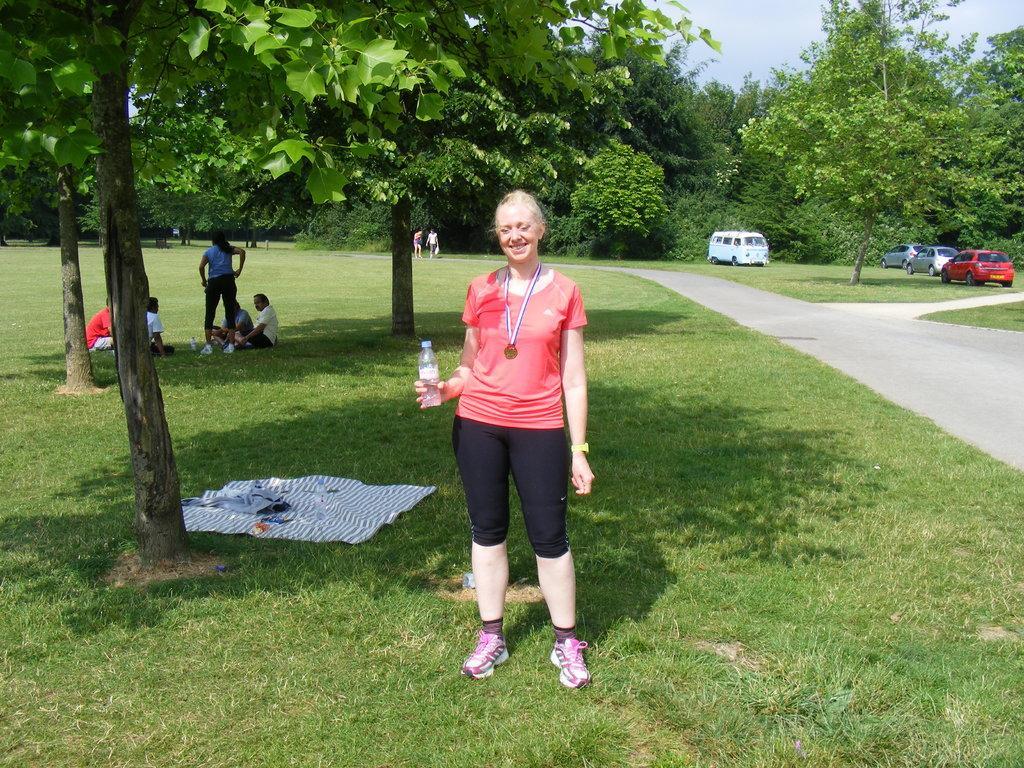Please provide a concise description of this image. In this picture I can see a woman standing and holding a bottle, there are some items on the grass, there are group of people, there are vehicles, there are trees, and in the background there is sky. 